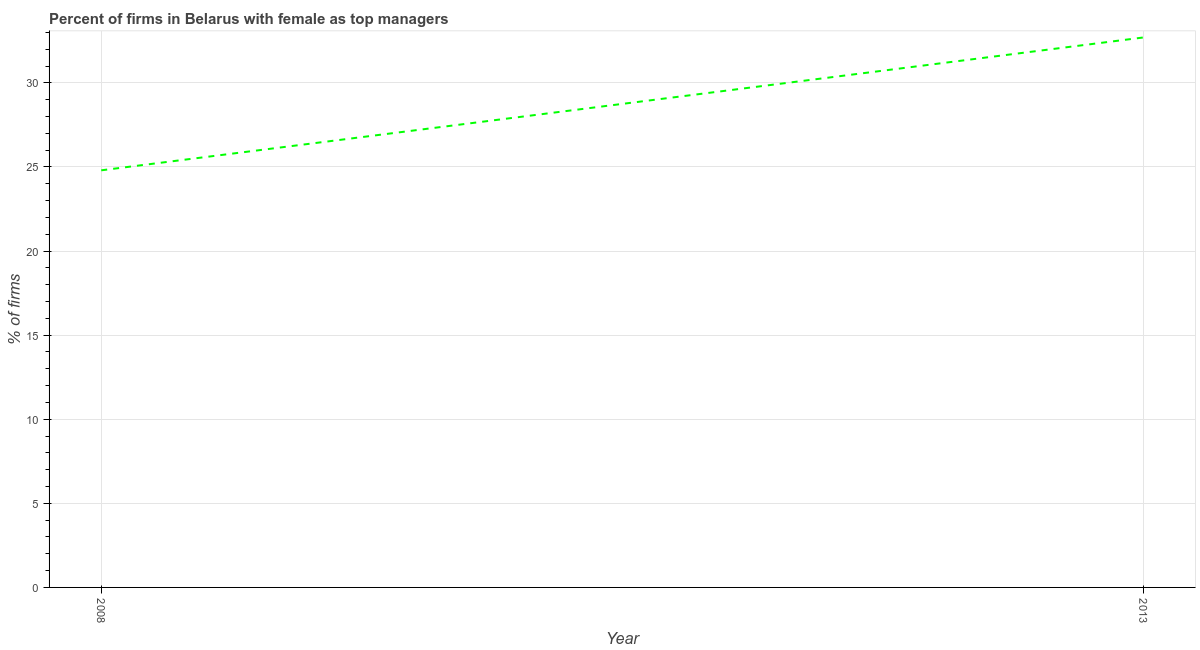What is the percentage of firms with female as top manager in 2013?
Provide a short and direct response. 32.7. Across all years, what is the maximum percentage of firms with female as top manager?
Give a very brief answer. 32.7. Across all years, what is the minimum percentage of firms with female as top manager?
Offer a very short reply. 24.8. In which year was the percentage of firms with female as top manager minimum?
Offer a very short reply. 2008. What is the sum of the percentage of firms with female as top manager?
Offer a terse response. 57.5. What is the difference between the percentage of firms with female as top manager in 2008 and 2013?
Your answer should be compact. -7.9. What is the average percentage of firms with female as top manager per year?
Ensure brevity in your answer.  28.75. What is the median percentage of firms with female as top manager?
Your answer should be very brief. 28.75. Do a majority of the years between 2013 and 2008 (inclusive) have percentage of firms with female as top manager greater than 17 %?
Give a very brief answer. No. What is the ratio of the percentage of firms with female as top manager in 2008 to that in 2013?
Provide a succinct answer. 0.76. Is the percentage of firms with female as top manager in 2008 less than that in 2013?
Provide a short and direct response. Yes. In how many years, is the percentage of firms with female as top manager greater than the average percentage of firms with female as top manager taken over all years?
Ensure brevity in your answer.  1. How many years are there in the graph?
Give a very brief answer. 2. What is the difference between two consecutive major ticks on the Y-axis?
Provide a succinct answer. 5. Does the graph contain any zero values?
Provide a succinct answer. No. Does the graph contain grids?
Your answer should be compact. Yes. What is the title of the graph?
Ensure brevity in your answer.  Percent of firms in Belarus with female as top managers. What is the label or title of the X-axis?
Offer a very short reply. Year. What is the label or title of the Y-axis?
Keep it short and to the point. % of firms. What is the % of firms of 2008?
Provide a succinct answer. 24.8. What is the % of firms of 2013?
Give a very brief answer. 32.7. What is the ratio of the % of firms in 2008 to that in 2013?
Make the answer very short. 0.76. 